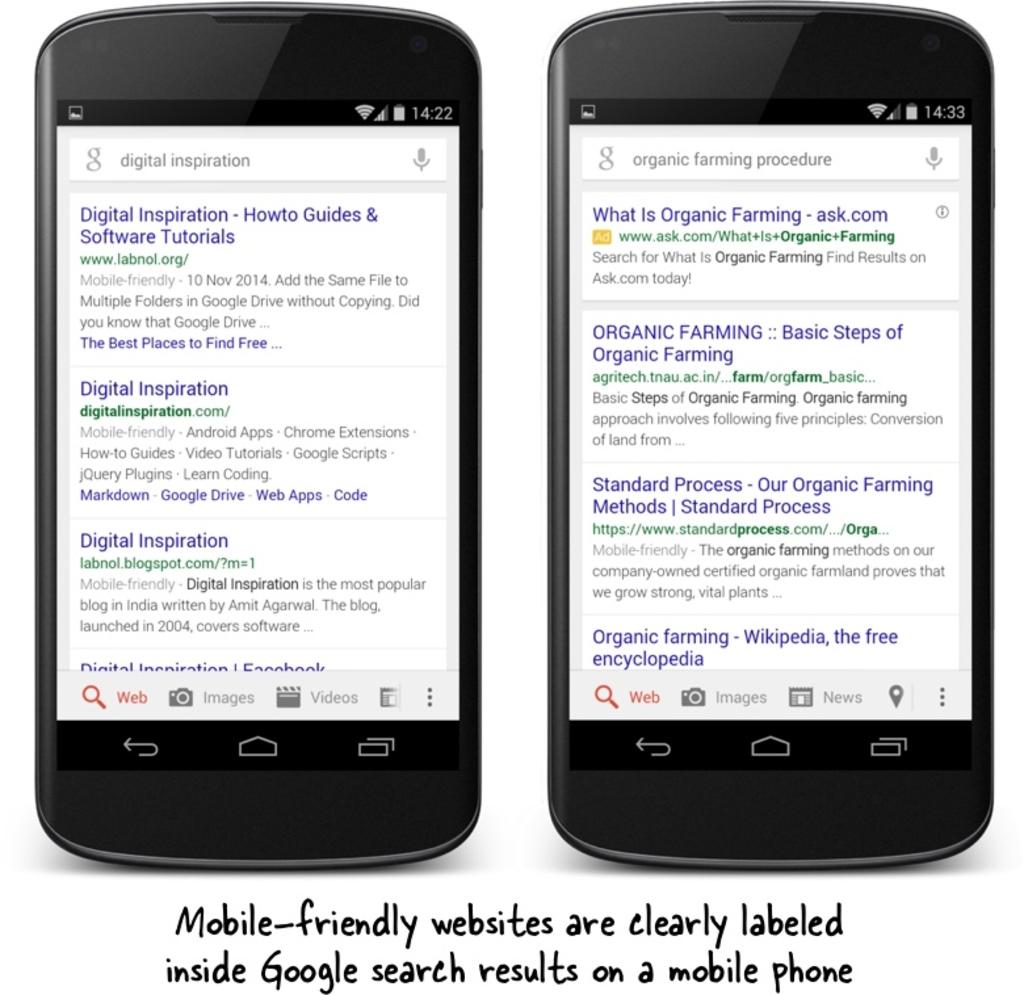What kind of websites are discussed?
Provide a short and direct response. Mobile friendly. What website produced these results?
Your answer should be very brief. Google. 